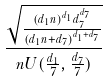Convert formula to latex. <formula><loc_0><loc_0><loc_500><loc_500>\frac { \sqrt { \frac { ( d _ { 1 } n ) ^ { d _ { 1 } } d _ { 7 } ^ { d _ { 7 } } } { ( d _ { 1 } n + d _ { 7 } ) ^ { d _ { 1 } + d _ { 7 } } } } } { n U ( \frac { d _ { 1 } } { 7 } , \frac { d _ { 7 } } { 7 } ) }</formula> 